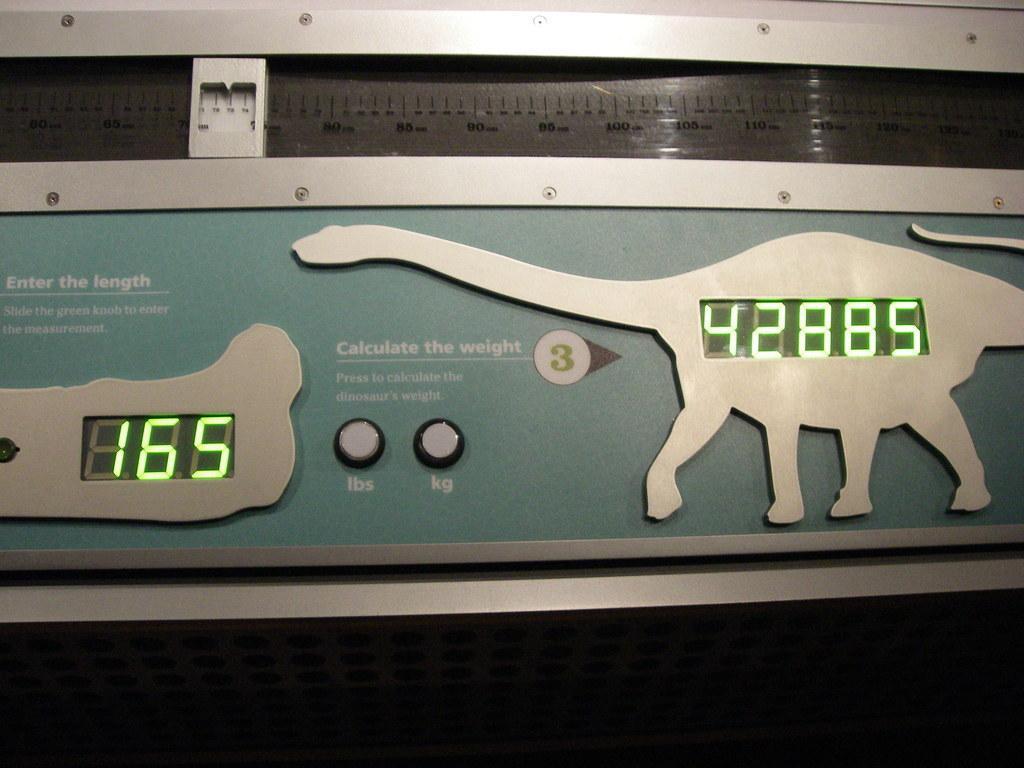Please provide a concise description of this image. This is a weight calculating device. 